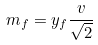<formula> <loc_0><loc_0><loc_500><loc_500>m _ { f } = y _ { f } \frac { v } { \sqrt { 2 } }</formula> 